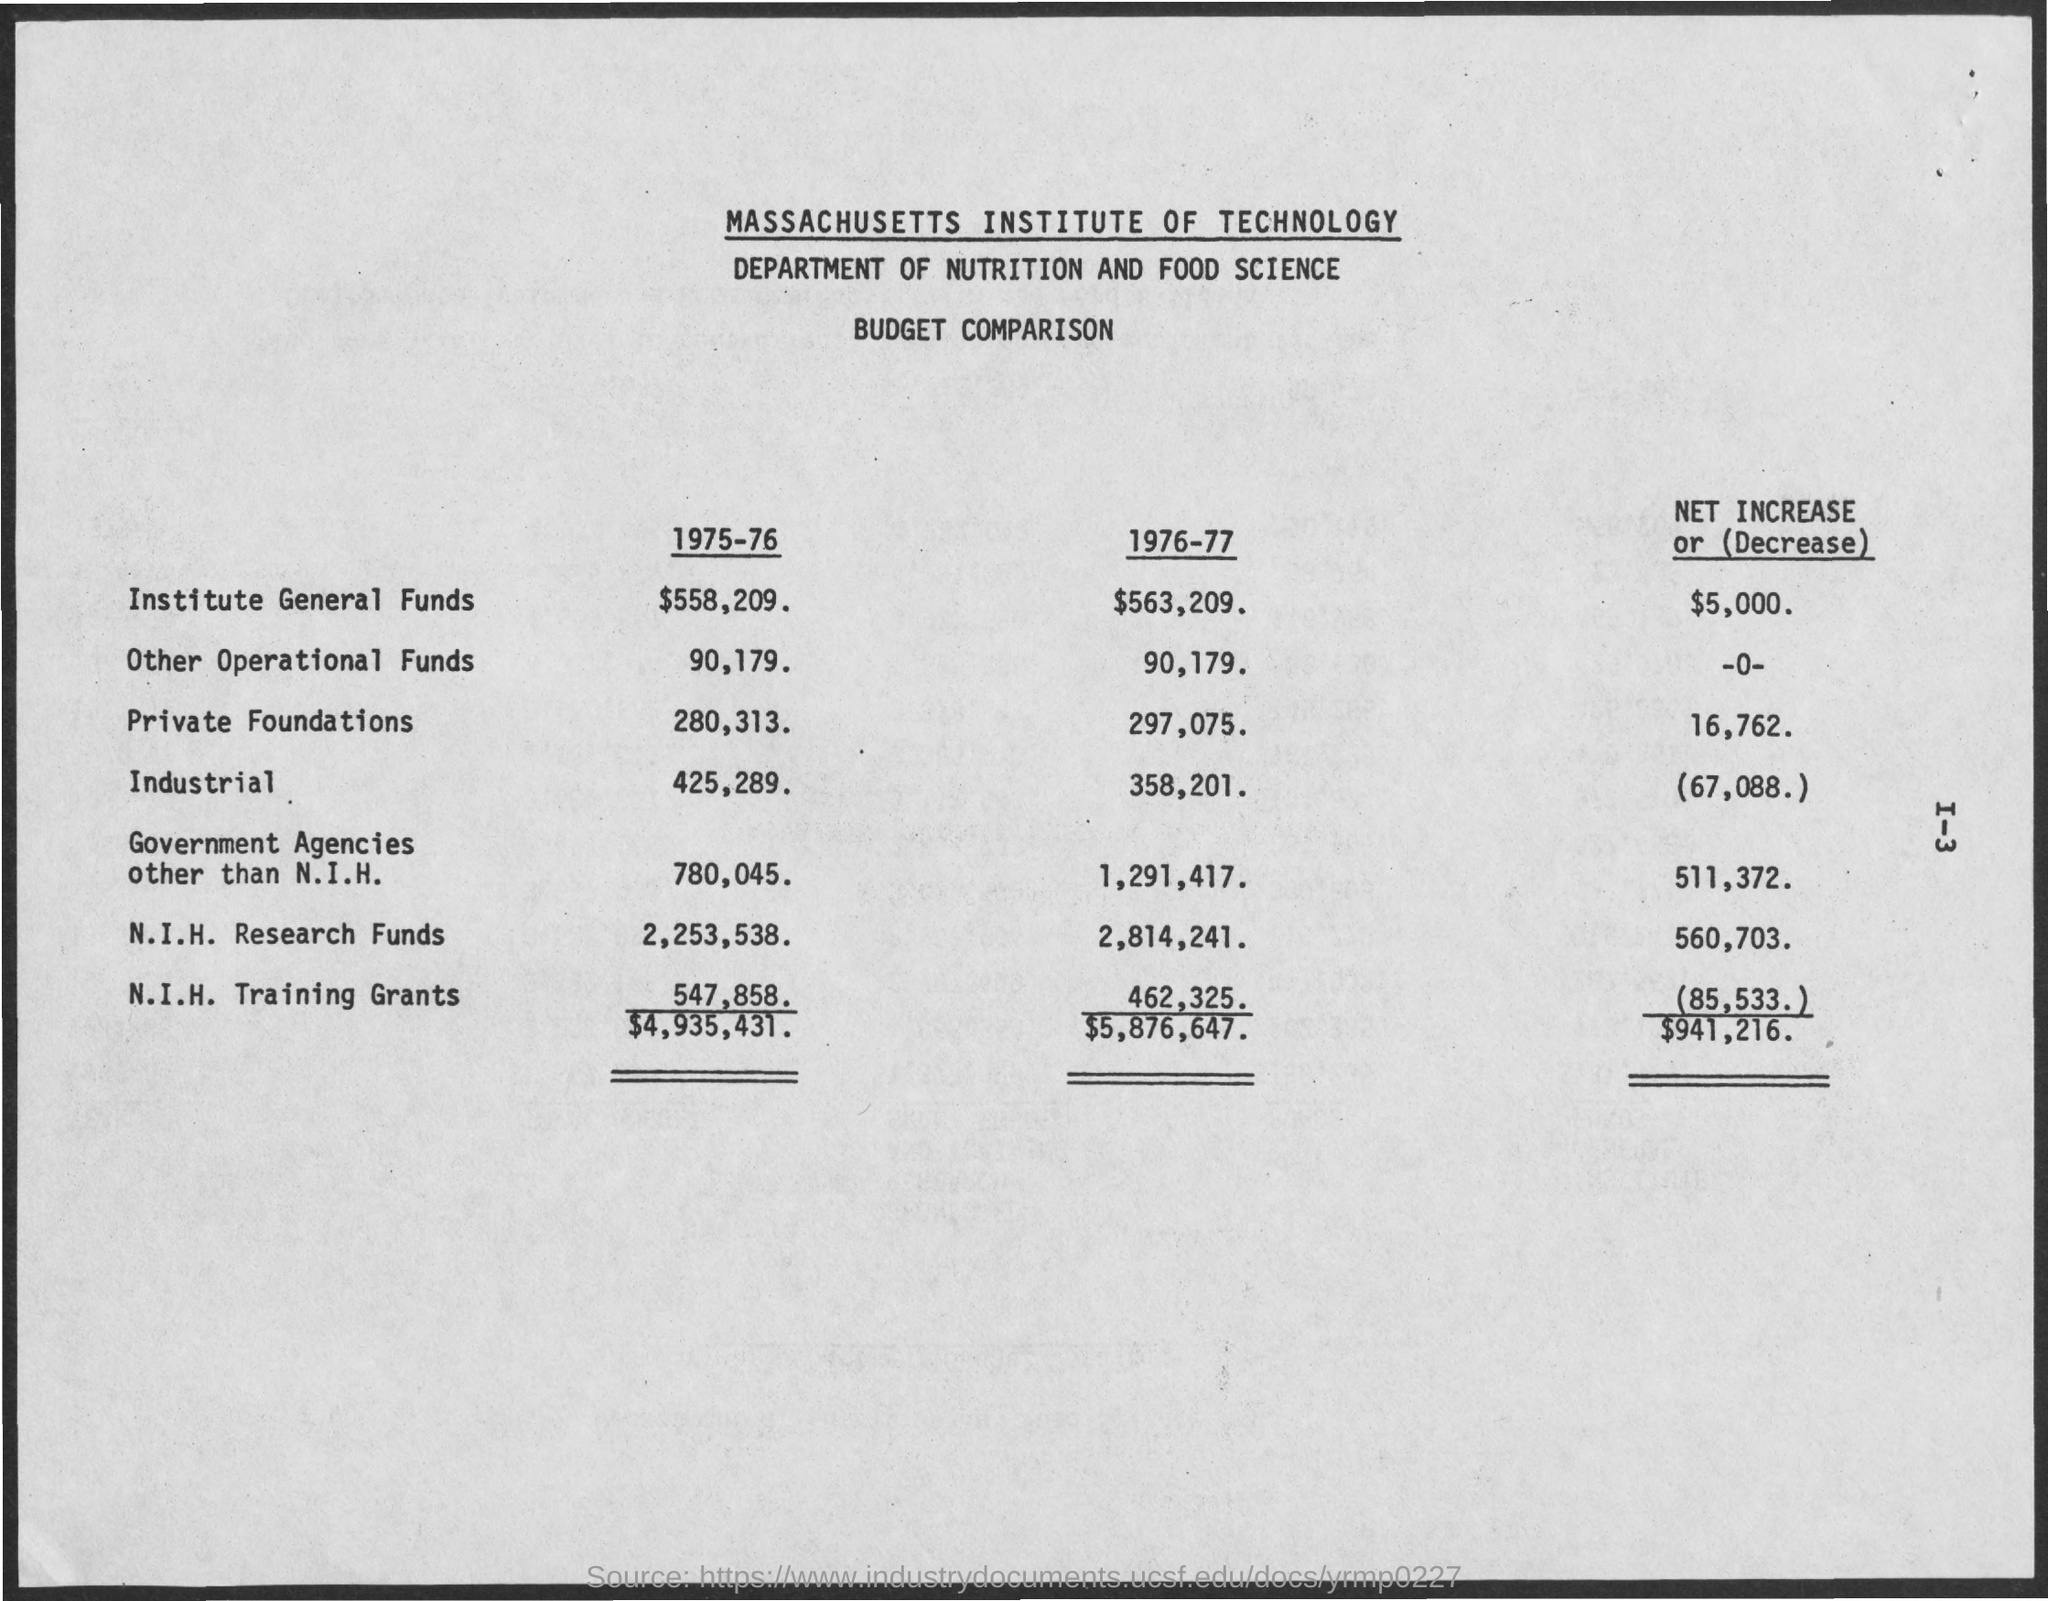Which category experienced the largest absolute decrease in funding from 1975-76 to 1976-77? From 1975-76 to 1976-77, the 'Industrial' category experienced the largest absolute decrease in funding, with a reduction of $67,088, bringing the funds down to $358,201 from the previous year's $425,289. 